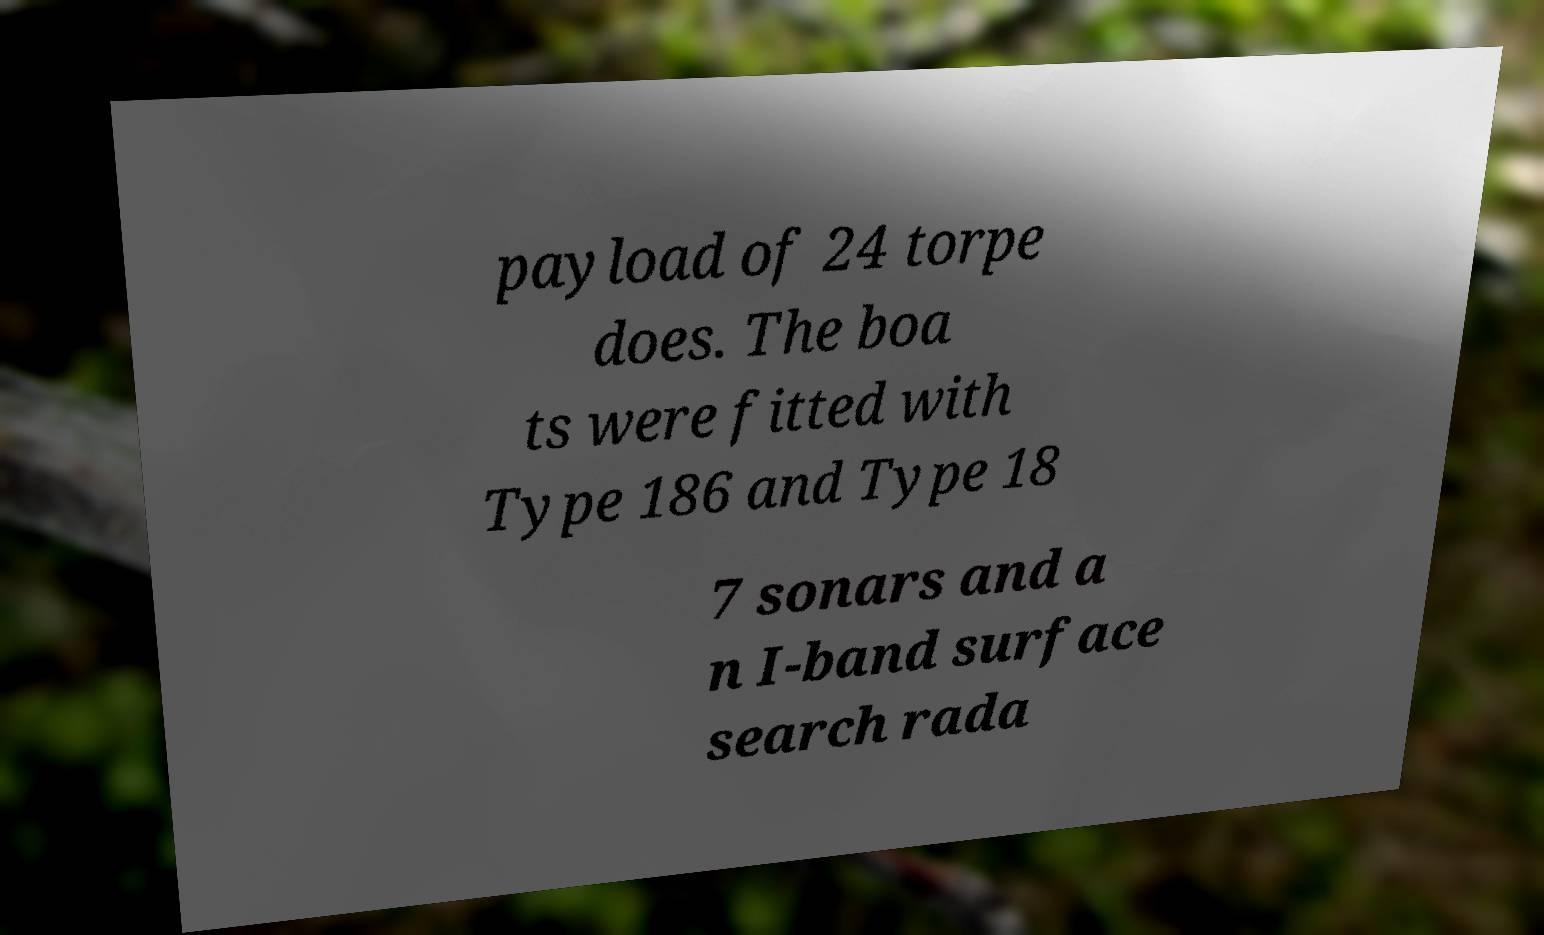What messages or text are displayed in this image? I need them in a readable, typed format. payload of 24 torpe does. The boa ts were fitted with Type 186 and Type 18 7 sonars and a n I-band surface search rada 